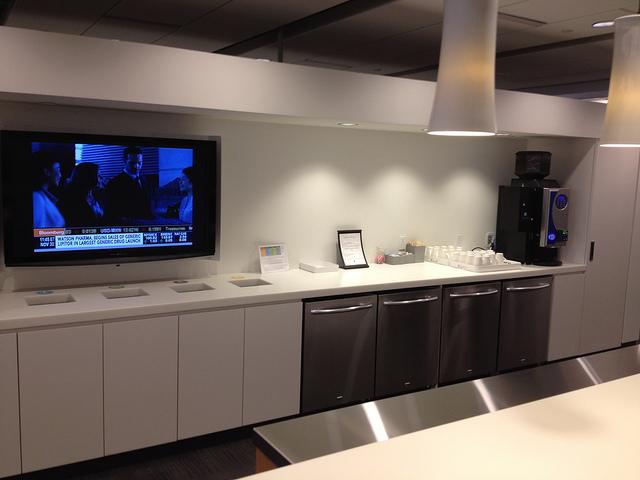What's playing on the TV?
Concise answer only. News. What kind of animal is displayed on the television?
Quick response, please. None. Is the tv on?
Be succinct. Yes. Where is the mug?
Be succinct. On counter. Is this a living room?
Answer briefly. No. What is made by the machine all the way to the right of the counter?
Keep it brief. Coffee. 